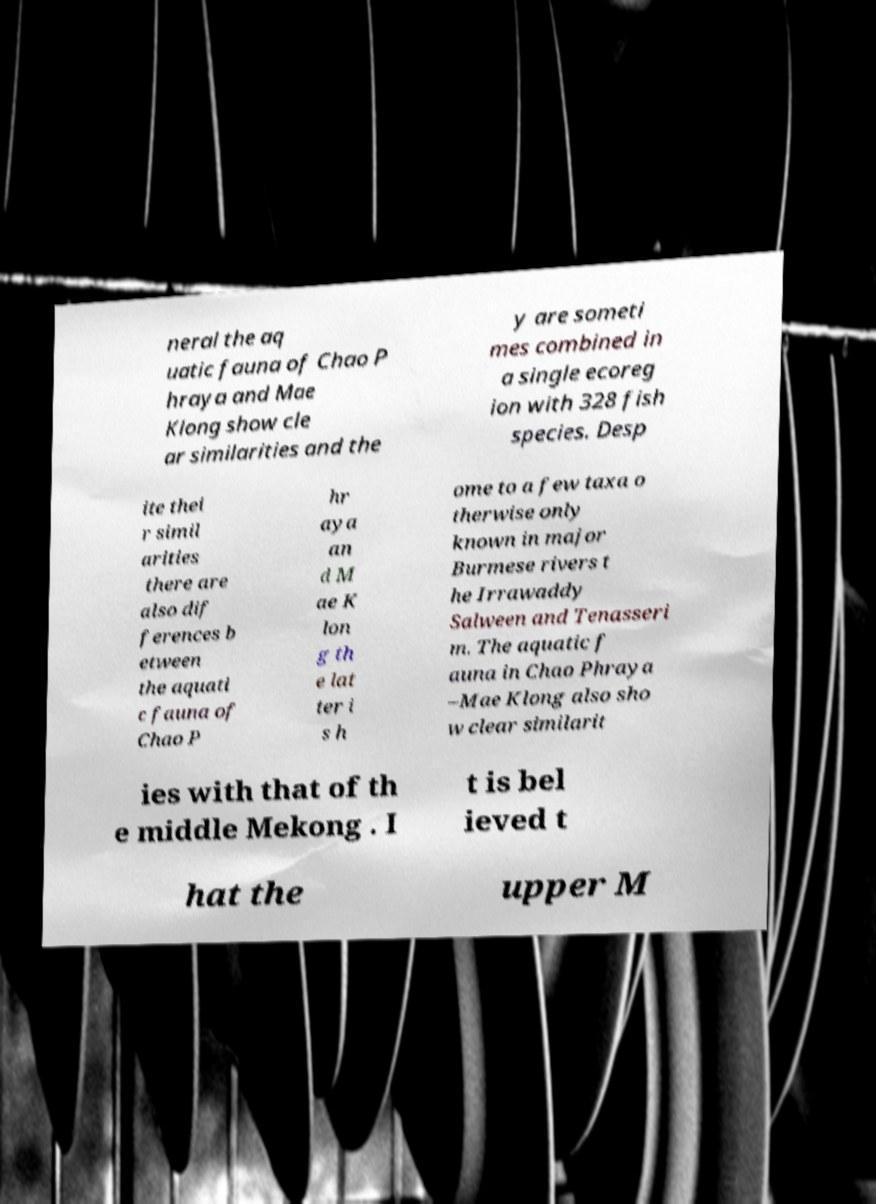Please read and relay the text visible in this image. What does it say? neral the aq uatic fauna of Chao P hraya and Mae Klong show cle ar similarities and the y are someti mes combined in a single ecoreg ion with 328 fish species. Desp ite thei r simil arities there are also dif ferences b etween the aquati c fauna of Chao P hr aya an d M ae K lon g th e lat ter i s h ome to a few taxa o therwise only known in major Burmese rivers t he Irrawaddy Salween and Tenasseri m. The aquatic f auna in Chao Phraya –Mae Klong also sho w clear similarit ies with that of th e middle Mekong . I t is bel ieved t hat the upper M 